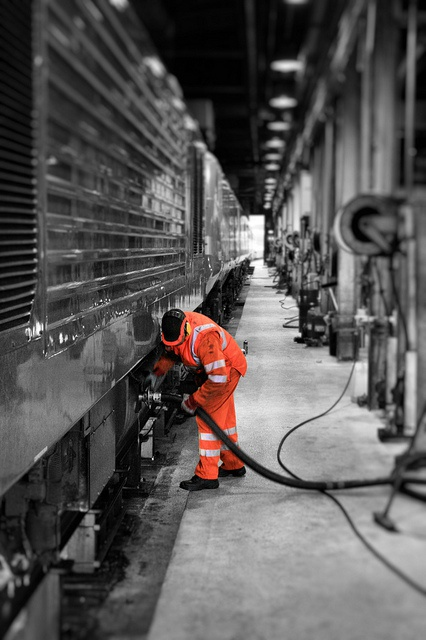Describe the objects in this image and their specific colors. I can see train in black, gray, darkgray, and lightgray tones and people in black, red, brown, and maroon tones in this image. 